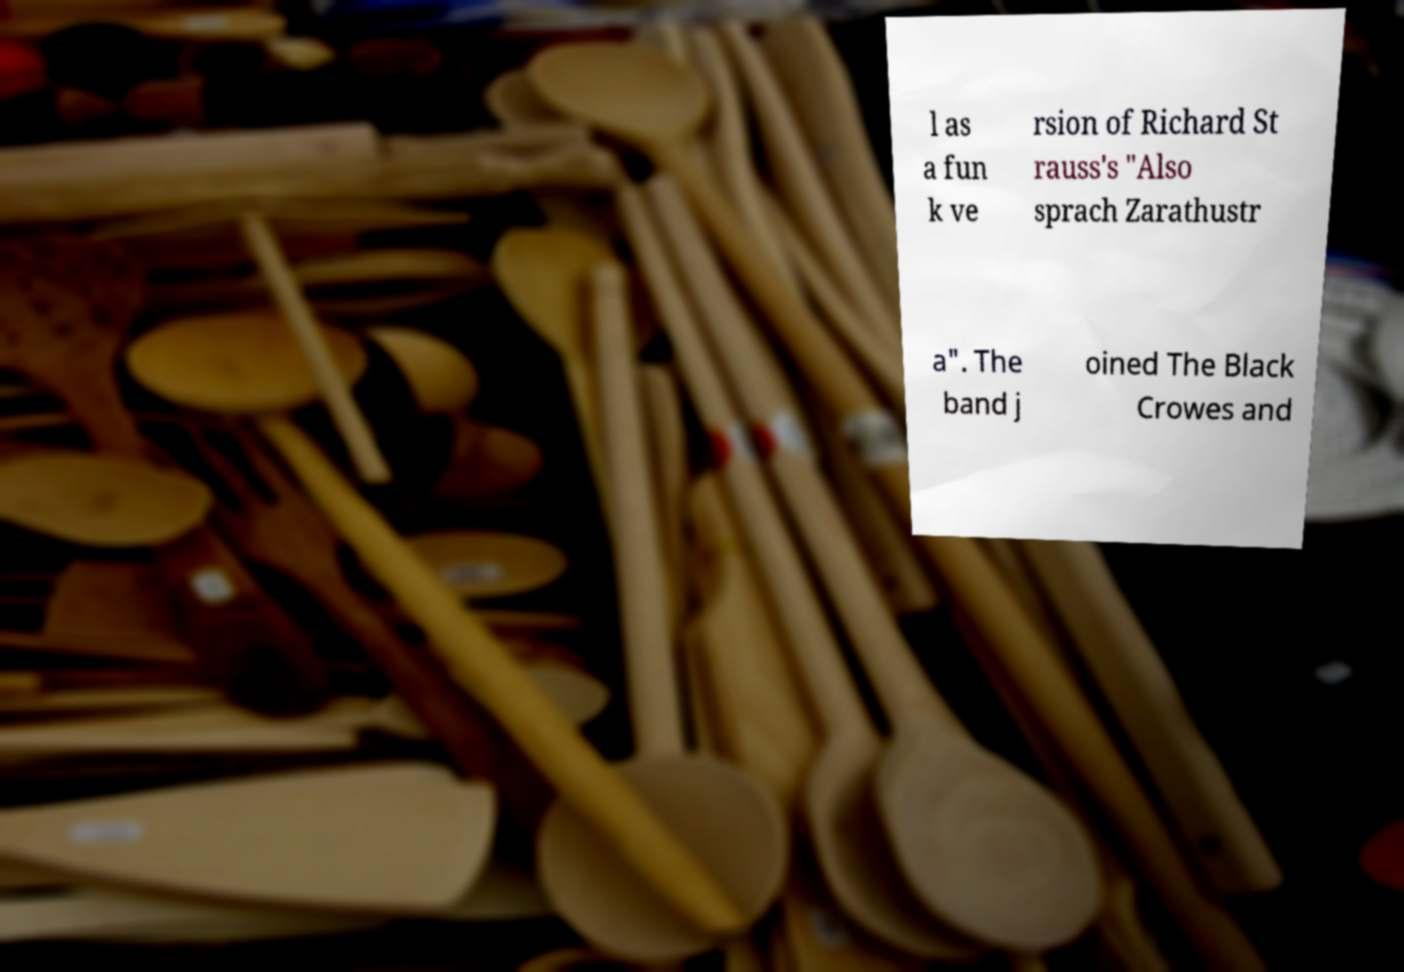Can you read and provide the text displayed in the image?This photo seems to have some interesting text. Can you extract and type it out for me? l as a fun k ve rsion of Richard St rauss's "Also sprach Zarathustr a". The band j oined The Black Crowes and 